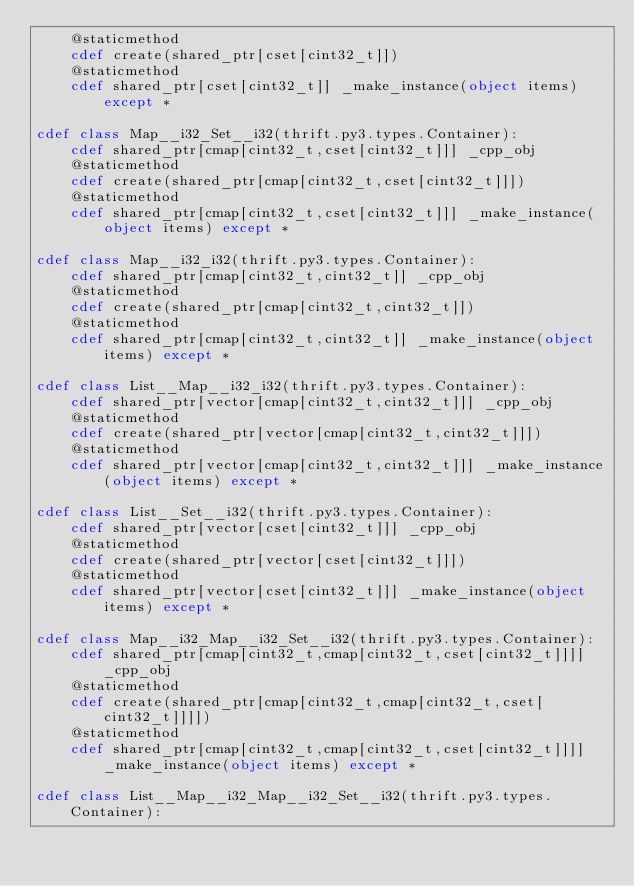<code> <loc_0><loc_0><loc_500><loc_500><_Cython_>    @staticmethod
    cdef create(shared_ptr[cset[cint32_t]])
    @staticmethod
    cdef shared_ptr[cset[cint32_t]] _make_instance(object items) except *

cdef class Map__i32_Set__i32(thrift.py3.types.Container):
    cdef shared_ptr[cmap[cint32_t,cset[cint32_t]]] _cpp_obj
    @staticmethod
    cdef create(shared_ptr[cmap[cint32_t,cset[cint32_t]]])
    @staticmethod
    cdef shared_ptr[cmap[cint32_t,cset[cint32_t]]] _make_instance(object items) except *

cdef class Map__i32_i32(thrift.py3.types.Container):
    cdef shared_ptr[cmap[cint32_t,cint32_t]] _cpp_obj
    @staticmethod
    cdef create(shared_ptr[cmap[cint32_t,cint32_t]])
    @staticmethod
    cdef shared_ptr[cmap[cint32_t,cint32_t]] _make_instance(object items) except *

cdef class List__Map__i32_i32(thrift.py3.types.Container):
    cdef shared_ptr[vector[cmap[cint32_t,cint32_t]]] _cpp_obj
    @staticmethod
    cdef create(shared_ptr[vector[cmap[cint32_t,cint32_t]]])
    @staticmethod
    cdef shared_ptr[vector[cmap[cint32_t,cint32_t]]] _make_instance(object items) except *

cdef class List__Set__i32(thrift.py3.types.Container):
    cdef shared_ptr[vector[cset[cint32_t]]] _cpp_obj
    @staticmethod
    cdef create(shared_ptr[vector[cset[cint32_t]]])
    @staticmethod
    cdef shared_ptr[vector[cset[cint32_t]]] _make_instance(object items) except *

cdef class Map__i32_Map__i32_Set__i32(thrift.py3.types.Container):
    cdef shared_ptr[cmap[cint32_t,cmap[cint32_t,cset[cint32_t]]]] _cpp_obj
    @staticmethod
    cdef create(shared_ptr[cmap[cint32_t,cmap[cint32_t,cset[cint32_t]]]])
    @staticmethod
    cdef shared_ptr[cmap[cint32_t,cmap[cint32_t,cset[cint32_t]]]] _make_instance(object items) except *

cdef class List__Map__i32_Map__i32_Set__i32(thrift.py3.types.Container):</code> 